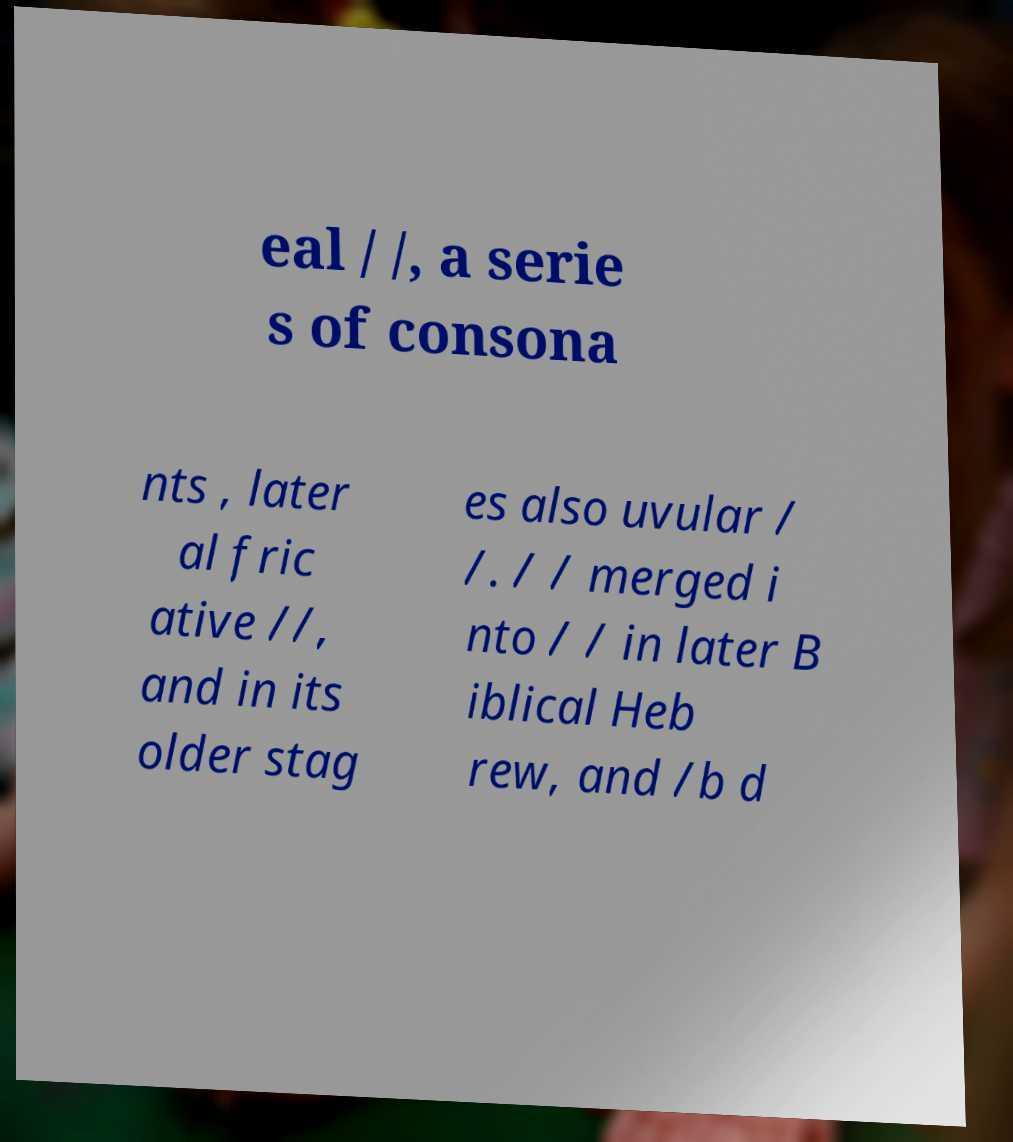Can you accurately transcribe the text from the provided image for me? eal / /, a serie s of consona nts , later al fric ative //, and in its older stag es also uvular / /. / / merged i nto / / in later B iblical Heb rew, and /b d 